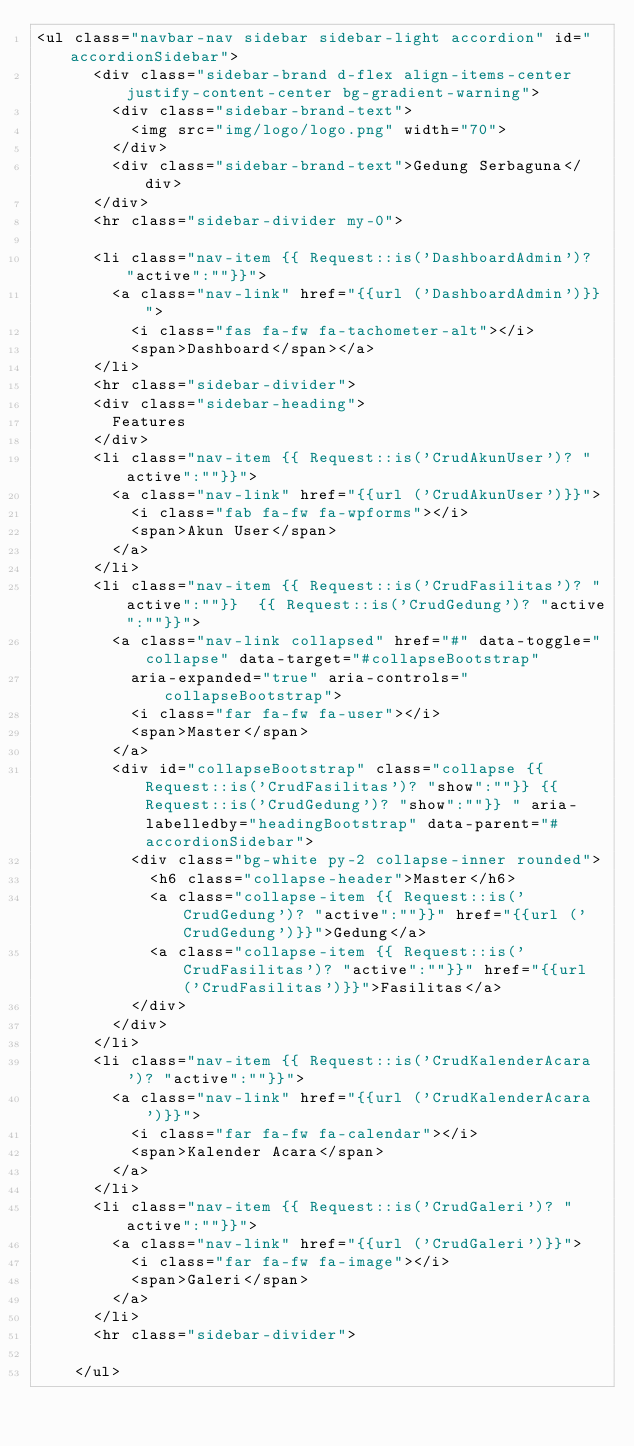<code> <loc_0><loc_0><loc_500><loc_500><_PHP_><ul class="navbar-nav sidebar sidebar-light accordion" id="accordionSidebar">
      <div class="sidebar-brand d-flex align-items-center justify-content-center bg-gradient-warning">
        <div class="sidebar-brand-text">
          <img src="img/logo/logo.png" width="70">
        </div>
        <div class="sidebar-brand-text">Gedung Serbaguna</div>
      </div>
      <hr class="sidebar-divider my-0">

      <li class="nav-item {{ Request::is('DashboardAdmin')? "active":""}}">
        <a class="nav-link" href="{{url ('DashboardAdmin')}}">
          <i class="fas fa-fw fa-tachometer-alt"></i>
          <span>Dashboard</span></a>
      </li>
      <hr class="sidebar-divider">
      <div class="sidebar-heading">
        Features
      </div>
      <li class="nav-item {{ Request::is('CrudAkunUser')? "active":""}}">
        <a class="nav-link" href="{{url ('CrudAkunUser')}}">
          <i class="fab fa-fw fa-wpforms"></i>
          <span>Akun User</span>
        </a>
      </li>
      <li class="nav-item {{ Request::is('CrudFasilitas')? "active":""}}  {{ Request::is('CrudGedung')? "active":""}}">
        <a class="nav-link collapsed" href="#" data-toggle="collapse" data-target="#collapseBootstrap"
          aria-expanded="true" aria-controls="collapseBootstrap">
          <i class="far fa-fw fa-user"></i>
          <span>Master</span>
        </a>
        <div id="collapseBootstrap" class="collapse {{ Request::is('CrudFasilitas')? "show":""}} {{ Request::is('CrudGedung')? "show":""}} " aria-labelledby="headingBootstrap" data-parent="#accordionSidebar">
          <div class="bg-white py-2 collapse-inner rounded">
            <h6 class="collapse-header">Master</h6>
            <a class="collapse-item {{ Request::is('CrudGedung')? "active":""}}" href="{{url ('CrudGedung')}}">Gedung</a>
            <a class="collapse-item {{ Request::is('CrudFasilitas')? "active":""}}" href="{{url ('CrudFasilitas')}}">Fasilitas</a>
          </div>
        </div>
      </li>
      <li class="nav-item {{ Request::is('CrudKalenderAcara')? "active":""}}">
        <a class="nav-link" href="{{url ('CrudKalenderAcara')}}">
          <i class="far fa-fw fa-calendar"></i>
          <span>Kalender Acara</span>
        </a>
      </li>
      <li class="nav-item {{ Request::is('CrudGaleri')? "active":""}}">
        <a class="nav-link" href="{{url ('CrudGaleri')}}">
          <i class="far fa-fw fa-image"></i>
          <span>Galeri</span>
        </a>
      </li>
      <hr class="sidebar-divider">
            
    </ul></code> 